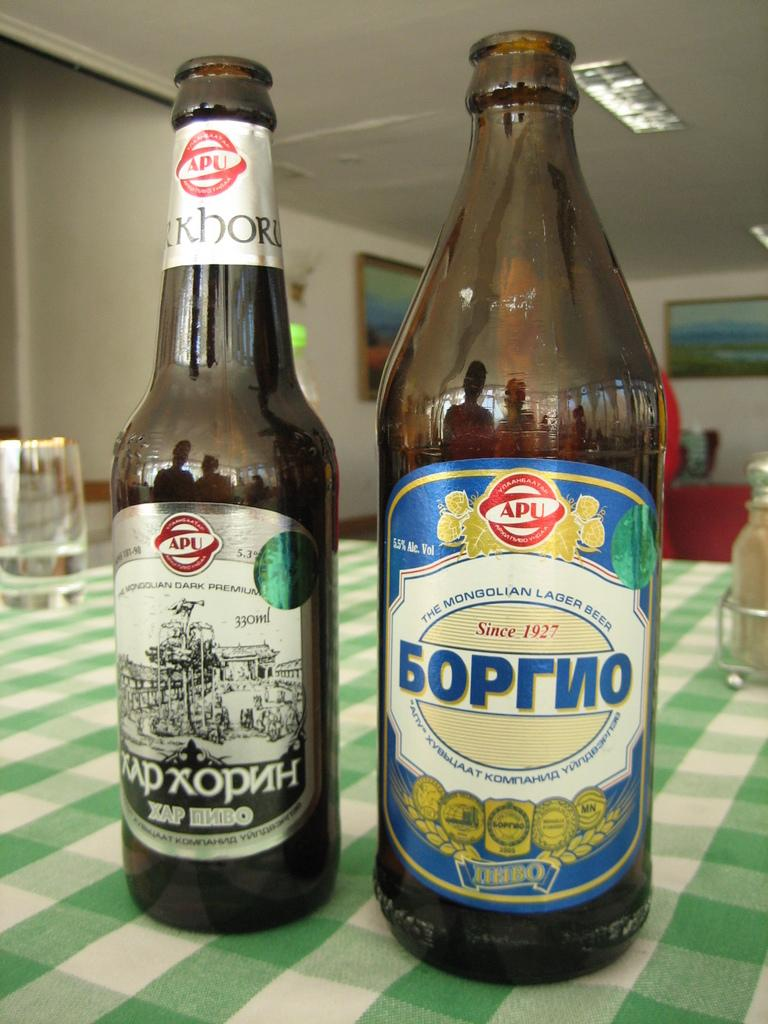<image>
Render a clear and concise summary of the photo. two bottles of Mongolian beer are on a table 